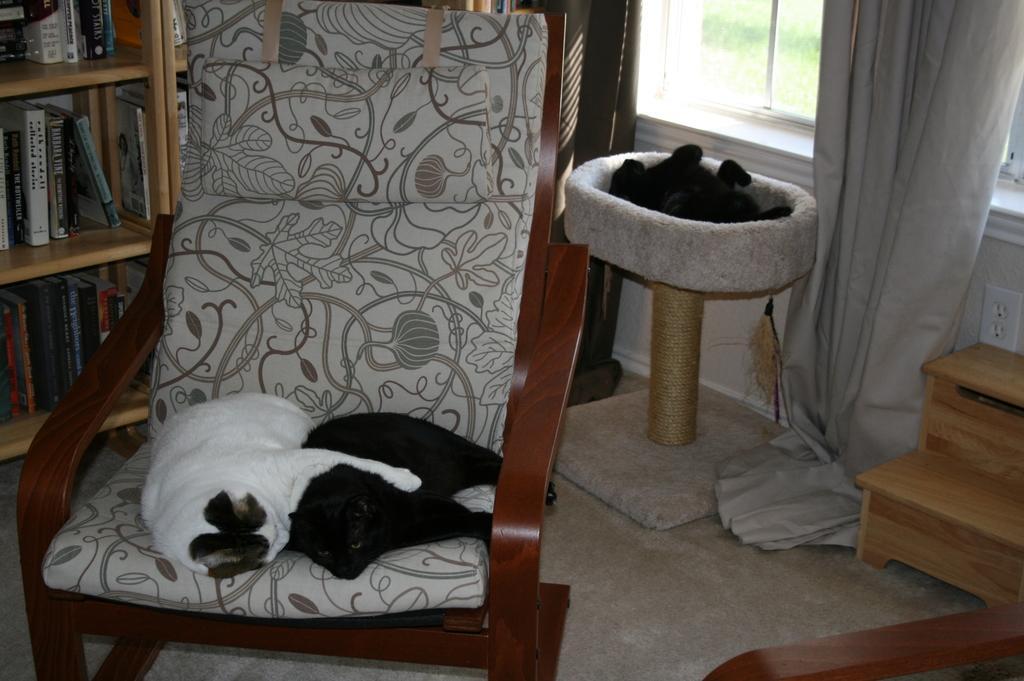Please provide a concise description of this image. The image consist of white and black cat sleeping on a chair,this looks like a living area and at back there are racks with full of books and over the right side there is window with curtain. 